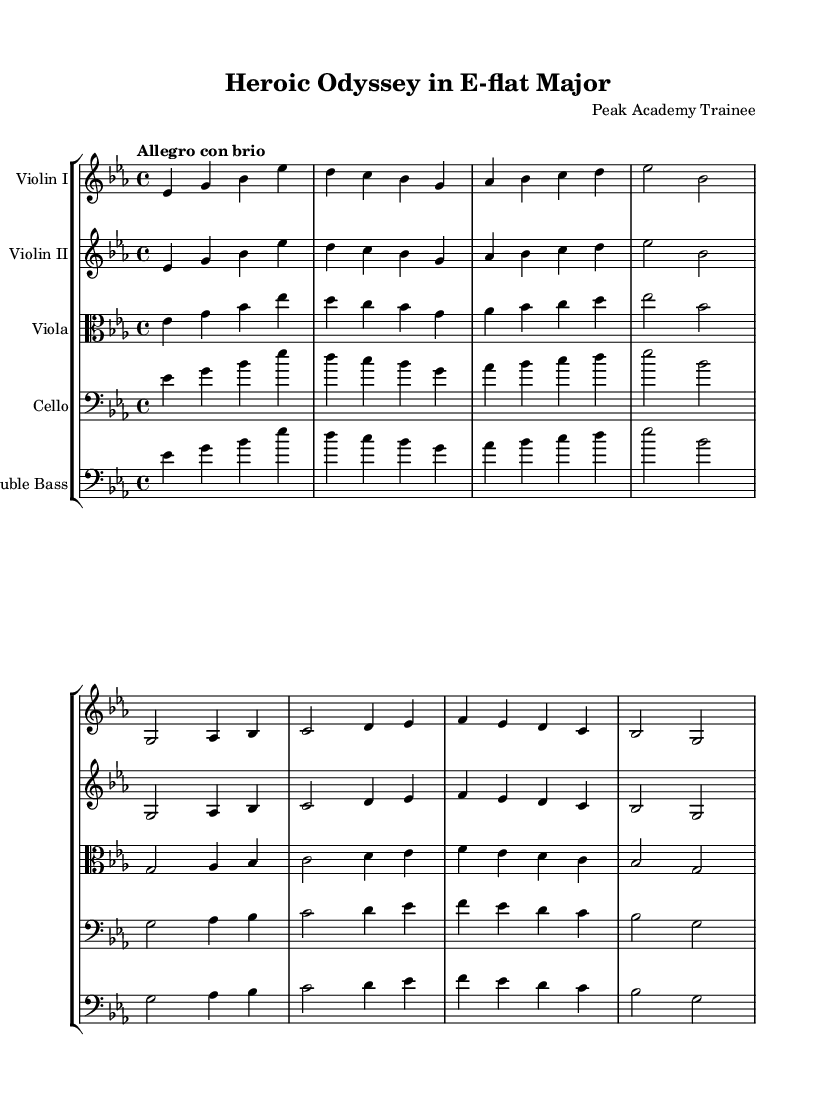What is the key signature of this music? The key signature is E-flat major, which has three flats (B, E, A). This can be determined by looking at the key signature indicated at the beginning of the staff.
Answer: E-flat major What is the time signature of this music? The time signature is 4/4, which is shown at the beginning of the score right after the key signature. This indicates there are four beats in each measure and the quarter note gets one beat.
Answer: 4/4 What is the tempo marking for this piece? The tempo marking is "Allegro con brio," which appears above the staff. "Allegro" indicates a fast and lively pace, while "con brio" suggests playing with spirit.
Answer: Allegro con brio Which instrument has a clef change? The viola has a clef change, as it is written using the alto clef, which is indicated at the beginning of its staff. This differs from the other string instruments that use the treble and bass clefs.
Answer: Viola How many measures are there in the main theme? The main theme consists of four measures, which can be counted by identifying the bar lines that separate each measure in the corresponding staff. Each section of music ends with a vertical line indicating the end of a measure.
Answer: Four Identify the two primary themes represented in the score. The two primary themes in the score are the main theme and the secondary theme, which are presented consecutively in each instrument's part. These are labeled in the code, and visually, they can be separated by their differing melodic content.
Answer: Main theme and secondary theme What form is suggested by the structure of this symphony? The structure of this symphony suggests a sonata form, which is typical for early Romantic symphonies. The presence of two distinct themes (the main theme and the secondary theme) and their development is indicative of this form.
Answer: Sonata form 